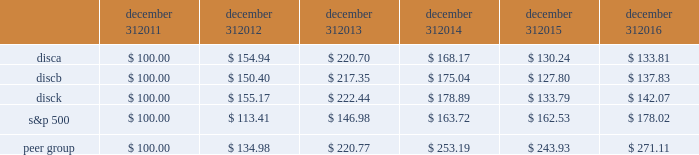December 31 , december 31 , december 31 , december 31 , december 31 , december 31 .
Equity compensation plan information information regarding securities authorized for issuance under equity compensation plans will be set forth in our definitive proxy statement for our 2017 annual meeting of stockholders under the caption 201csecurities authorized for issuance under equity compensation plans , 201d which is incorporated herein by reference .
Item 6 .
Selected financial data .
The table set forth below presents our selected financial information for each of the past five years ( in millions , except per share amounts ) .
The selected statement of operations information for each of the three years ended december 31 , 2016 and the selected balance sheet information as of december 31 , 2016 and 2015 have been derived from and should be read in conjunction with the information in item 7 , 201cmanagement 2019s discussion and analysis of financial condition and results of operations , 201d the audited consolidated financial statements included in item 8 , 201cfinancial statements and supplementary data , 201d and other financial information included elsewhere in this annual report on form 10-k .
The selected statement of operations information for each of the two years ended december 31 , 2013 and 2012 and the selected balance sheet information as of december 31 , 2014 , 2013 and 2012 have been derived from financial statements not included in this annual report on form 10-k .
2016 2015 2014 2013 2012 selected statement of operations information : revenues $ 6497 $ 6394 $ 6265 $ 5535 $ 4487 operating income 2058 1985 2061 1975 1859 income from continuing operations , net of taxes 1218 1048 1137 1077 956 loss from discontinued operations , net of taxes 2014 2014 2014 2014 ( 11 ) net income 1218 1048 1137 1077 945 net income available to discovery communications , inc .
1194 1034 1139 1075 943 basic earnings per share available to discovery communications , inc .
Series a , b and c common stockholders : continuing operations $ 1.97 $ 1.59 $ 1.67 $ 1.50 $ 1.27 discontinued operations 2014 2014 2014 2014 ( 0.01 ) net income 1.97 1.59 1.67 1.50 1.25 diluted earnings per share available to discovery communications , inc .
Series a , b and c common stockholders : continuing operations $ 1.96 $ 1.58 $ 1.66 $ 1.49 $ 1.26 discontinued operations 2014 2014 2014 2014 ( 0.01 ) net income 1.96 1.58 1.66 1.49 1.24 weighted average shares outstanding : basic 401 432 454 484 498 diluted 610 656 687 722 759 selected balance sheet information : cash and cash equivalents $ 300 $ 390 $ 367 $ 408 $ 1201 total assets 15758 15864 15970 14934 12892 long-term debt : current portion 82 119 1107 17 31 long-term portion 7841 7616 6002 6437 5174 total liabilities 10348 10172 9619 8701 6599 redeemable noncontrolling interests 243 241 747 36 2014 equity attributable to discovery communications , inc .
5167 5451 5602 6196 6291 total equity $ 5167 $ 5451 $ 5604 $ 6197 $ 6293 2022 income per share amounts may not sum since each is calculated independently .
2022 on september 30 , 2016 , the company recorded an other-than-temporary impairment of $ 62 million related to its investment in lionsgate .
On december 2 , 2016 , the company acquired a 39% ( 39 % ) minority interest in group nine media , a newly formed media holding company , in exchange for contributions of $ 100 million and the company's digital network businesses seeker and sourcefed , resulting in a gain of $ 50 million upon deconsolidation of the businesses .
( see note 4 to the accompanying consolidated financial statements. ) .
What was the percentage cumulative total shareholder return on disca for the five year period ended december 31 , 2016? 
Computations: ((133.81 - 100) / 100)
Answer: 0.3381. 